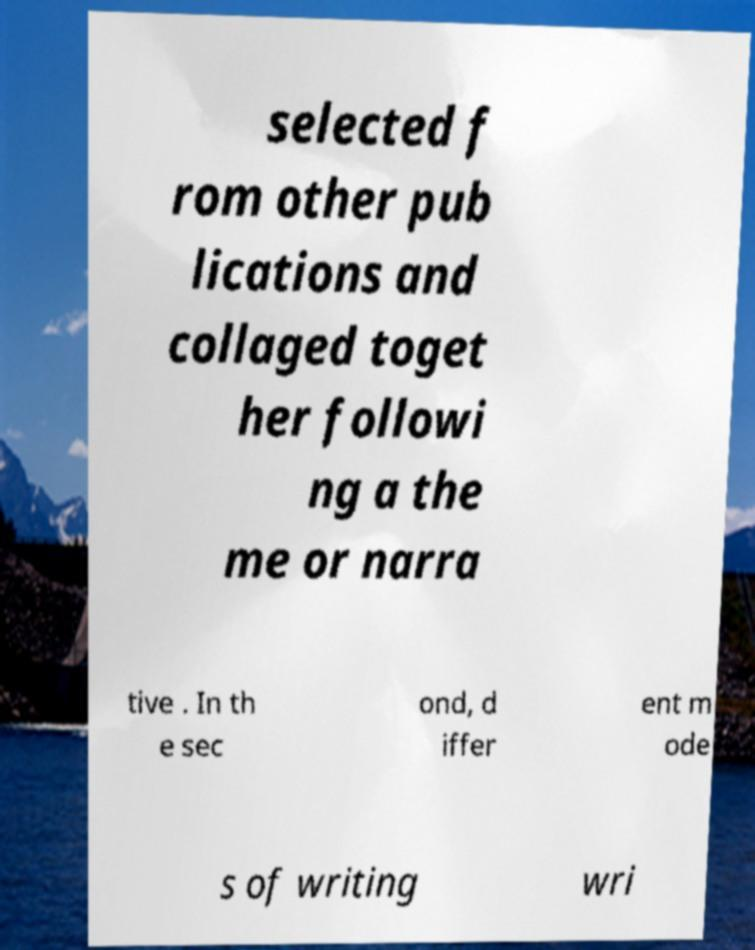Could you assist in decoding the text presented in this image and type it out clearly? selected f rom other pub lications and collaged toget her followi ng a the me or narra tive . In th e sec ond, d iffer ent m ode s of writing wri 